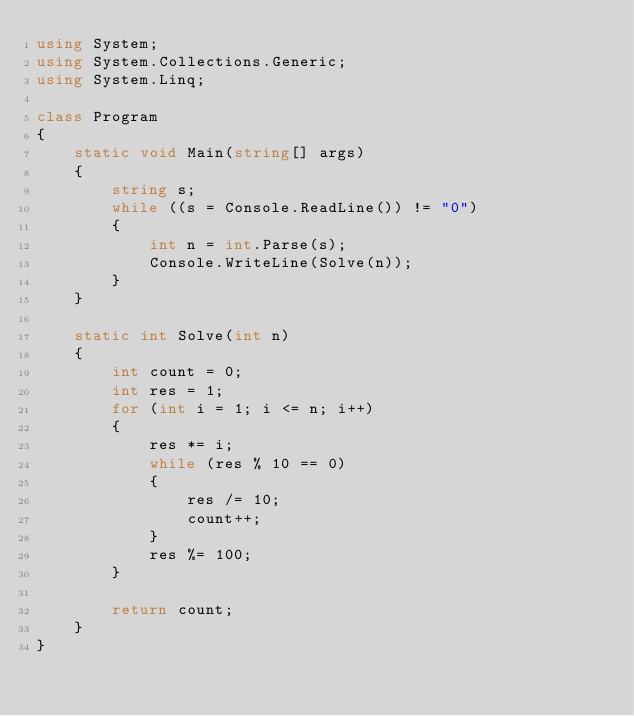Convert code to text. <code><loc_0><loc_0><loc_500><loc_500><_C#_>using System;
using System.Collections.Generic;
using System.Linq;

class Program
{
    static void Main(string[] args)
    {
        string s;
        while ((s = Console.ReadLine()) != "0")
        {
            int n = int.Parse(s);
            Console.WriteLine(Solve(n));
        }
    }

    static int Solve(int n)
    {
        int count = 0;
        int res = 1;
        for (int i = 1; i <= n; i++)
        {
            res *= i;
            while (res % 10 == 0)
            {
                res /= 10;
                count++;
            }
            res %= 100;
        }

        return count;
    }
}</code> 